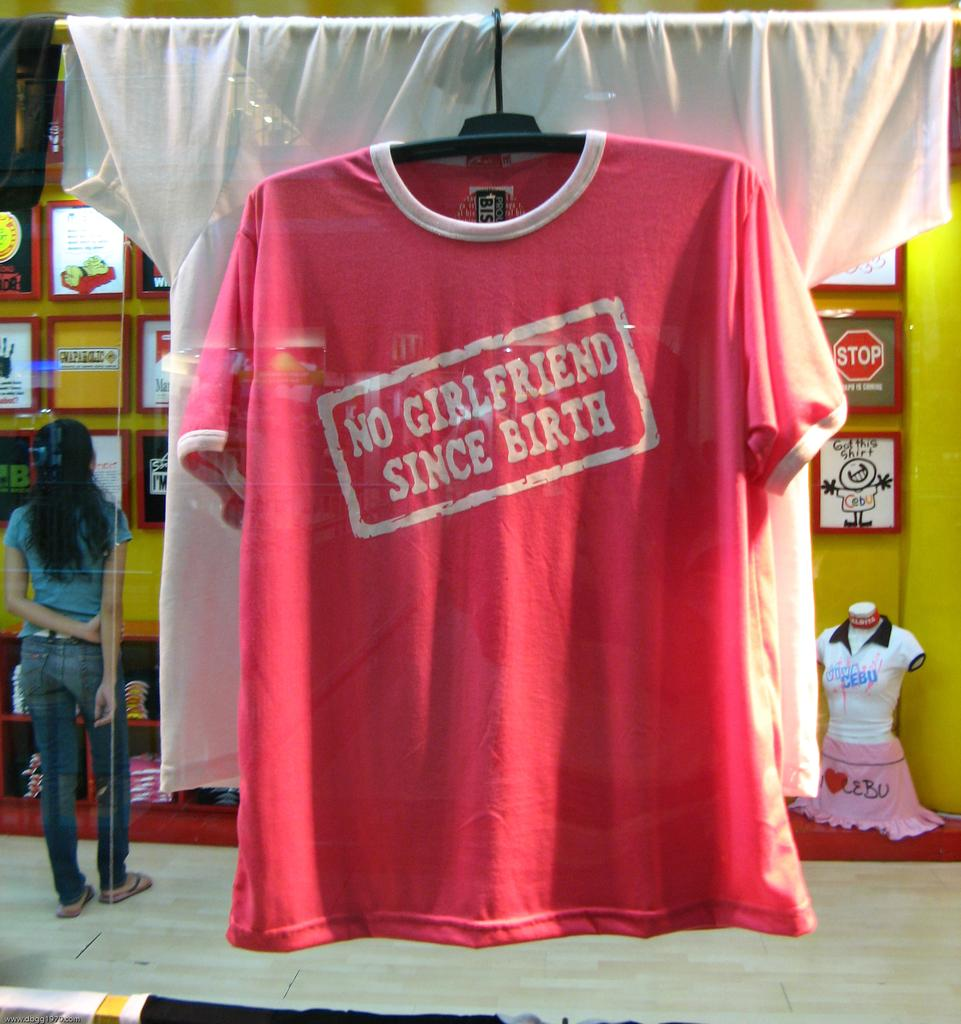<image>
Give a short and clear explanation of the subsequent image. A t-shirt with the word no on it is hanging on a hanger. 